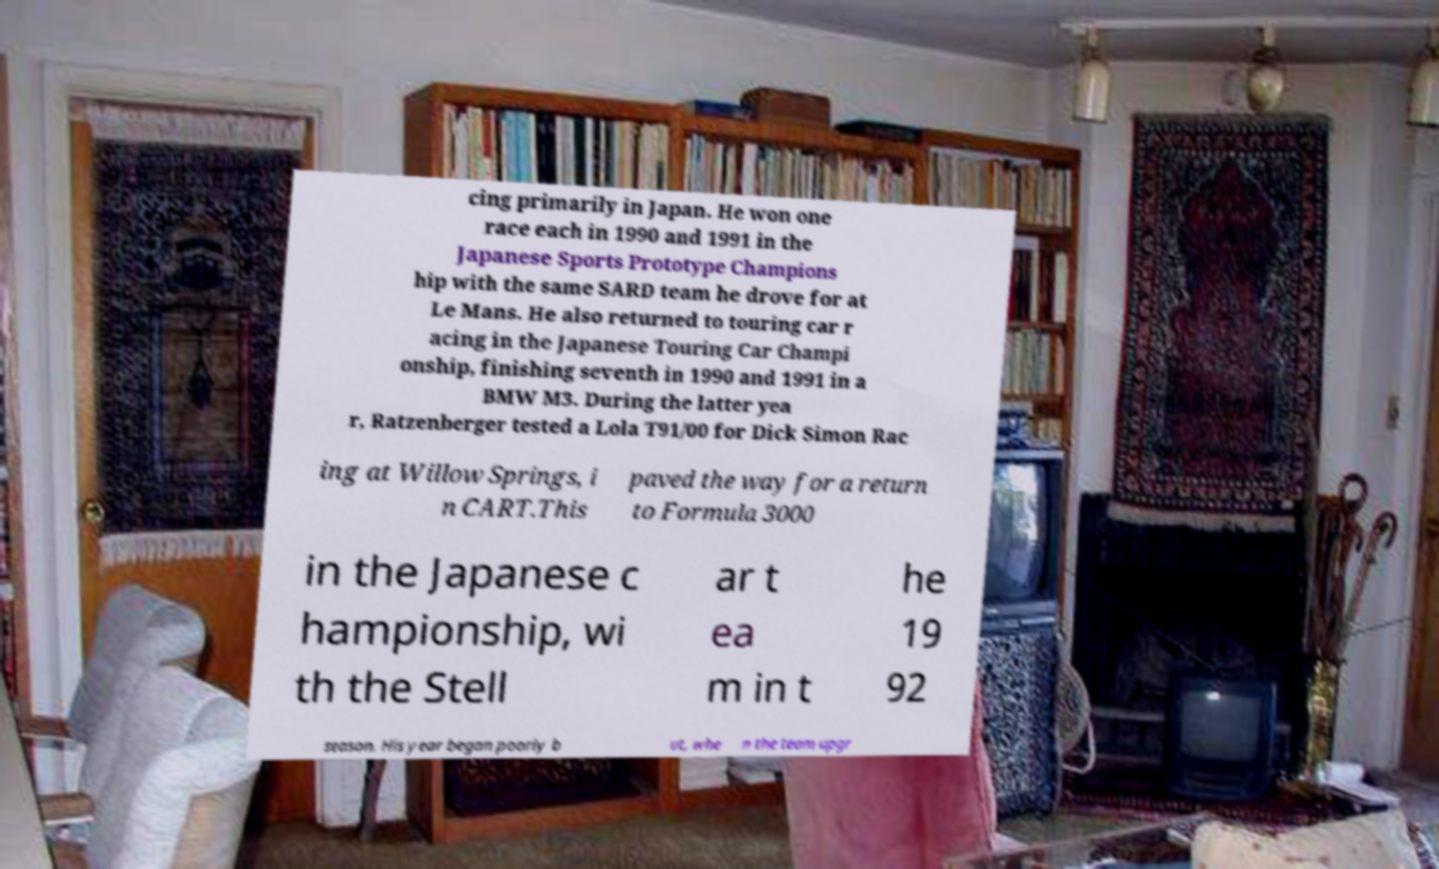Can you accurately transcribe the text from the provided image for me? cing primarily in Japan. He won one race each in 1990 and 1991 in the Japanese Sports Prototype Champions hip with the same SARD team he drove for at Le Mans. He also returned to touring car r acing in the Japanese Touring Car Champi onship, finishing seventh in 1990 and 1991 in a BMW M3. During the latter yea r, Ratzenberger tested a Lola T91/00 for Dick Simon Rac ing at Willow Springs, i n CART.This paved the way for a return to Formula 3000 in the Japanese c hampionship, wi th the Stell ar t ea m in t he 19 92 season. His year began poorly b ut, whe n the team upgr 